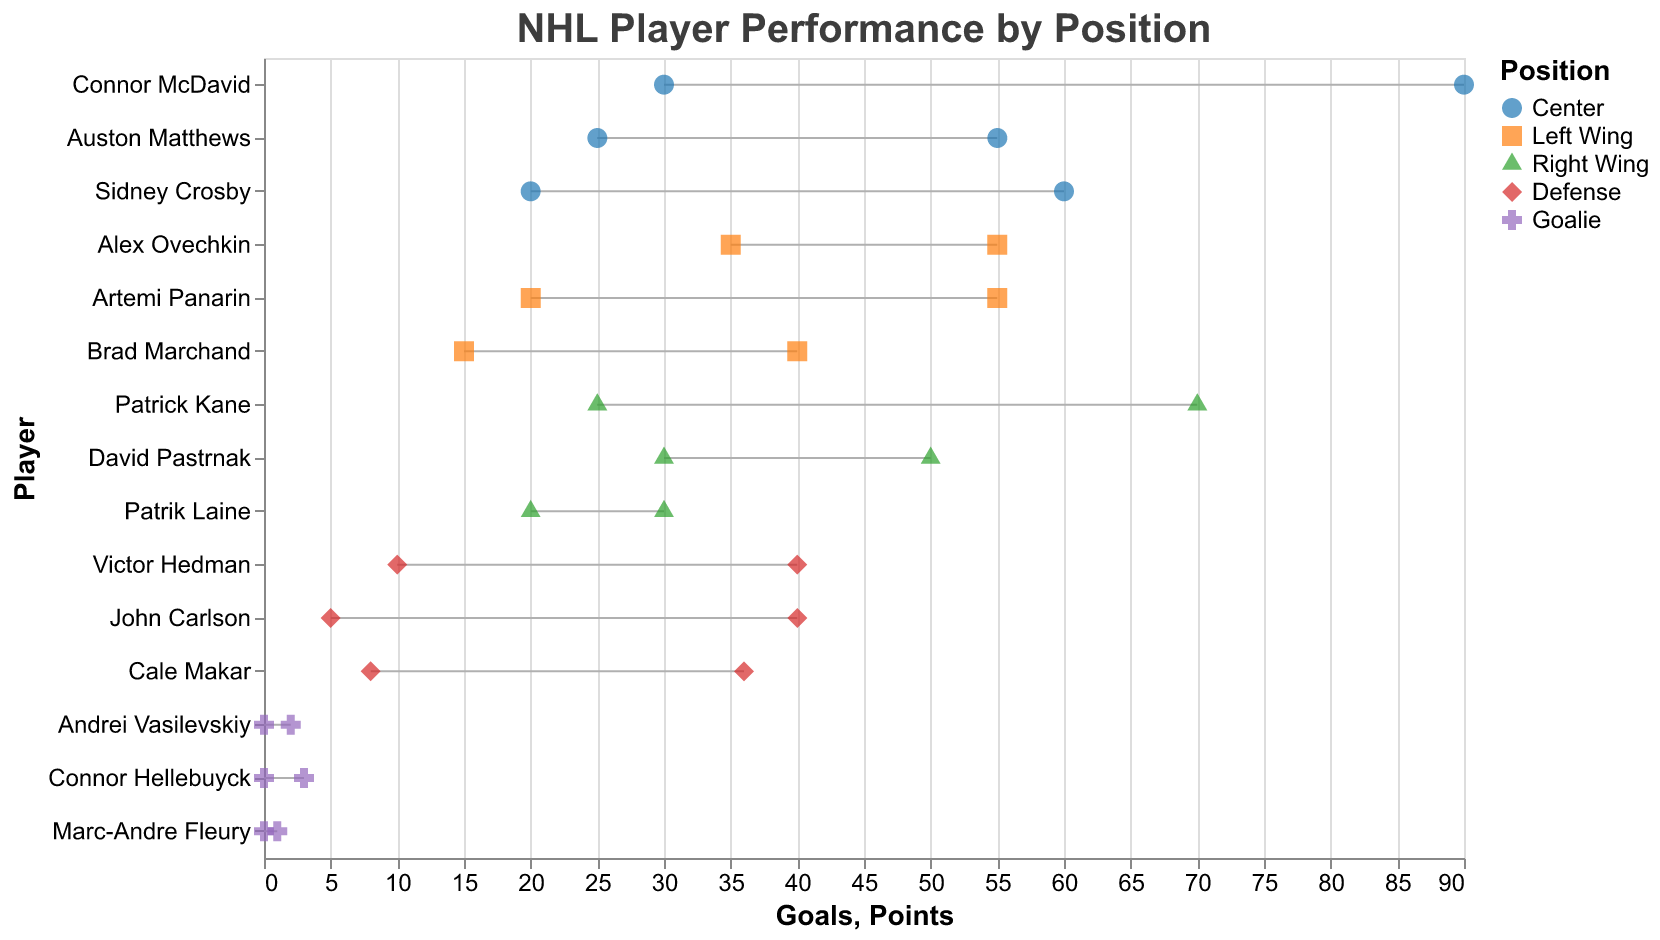What is the range of goals scored by Centers? The plot shows Connor McDavid with 30 goals being the highest and Sidney Crosby with 20 goals being the lowest among Centers. So, the range is from 20 to 30.
Answer: 20 to 30 Which player scored the most goals in the Left Wing position? The plot shows that Alex Ovechkin, a Left Wing, scored the highest with 35 goals.
Answer: Alex Ovechkin Compare the points of the player with the least number of goals among Right Wings. Patrik Laine scored the least goals (20) among Right Wings and has 30 points. All other Right Wings have more than 50 points.
Answer: Patrik Laine has the least points (30) What is the difference in points between the highest scoring Defense player and the highest scoring Center? Victor Hedman, the highest scoring Defense player, has 40 points. Connor McDavid, the highest scoring Center, has 90 points. The difference is 90 - 40 = 50.
Answer: 50 How many players have a position of Goalie in the dataset? The plot lists three players as Goalie: Andrei Vasilevskiy, Connor Hellebuyck, and Marc-Andre Fleury.
Answer: 3 Who among the players listed has the highest points? According to the plot, Connor McDavid has the highest points with 90.
Answer: Connor McDavid What is the average number of goals scored by Centers? Centers Connor McDavid (30), Auston Matthews (25), and Sidney Crosby (20) have a total of (30 + 25 + 20) = 75 goals. The average is 75 / 3 = 25.
Answer: 25 Identify the player with the most assists in the figure. The plot shows that Patrick Kane, a Right Wing, has the highest assists with 45.
Answer: Patrick Kane Is there any player who has the same number of goals and assists? By examining the plot, none of the players have the same number of goals and assists.
Answer: No What distinguishes the visual representation of Goalies compared to players of all other positions? Goalies are represented with a cross shape and purple color, while other positions have different shapes and colors.
Answer: Shape and color 